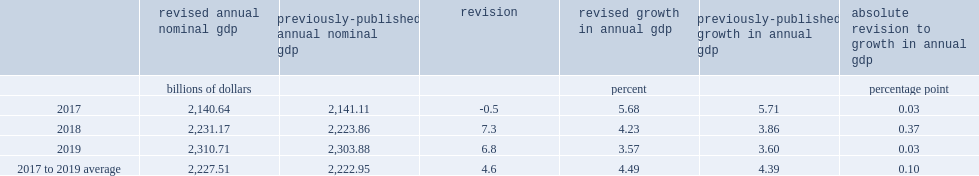How much did the level of nominal gdp revise down in 2017 with the incorporation of new benchmark data from the supply-use tables? 0.5. What was the percentage-poing of the nominal gdp growth rate downward revision? 0.03. How much did the level of nominal gdp revise upward in 2018? 7.3. What was the percentage point of the level of nominal gdp revised upward in 2018? 0.37. How much did the level of nominal gdp revise up in 2019? 6.8. What was the percentage point of the level of nominal gdp revised upward in 2019? 0.03. What was the percentage poing of the previously published average growth rate for the 2017-to-2019 period? 0.1. 